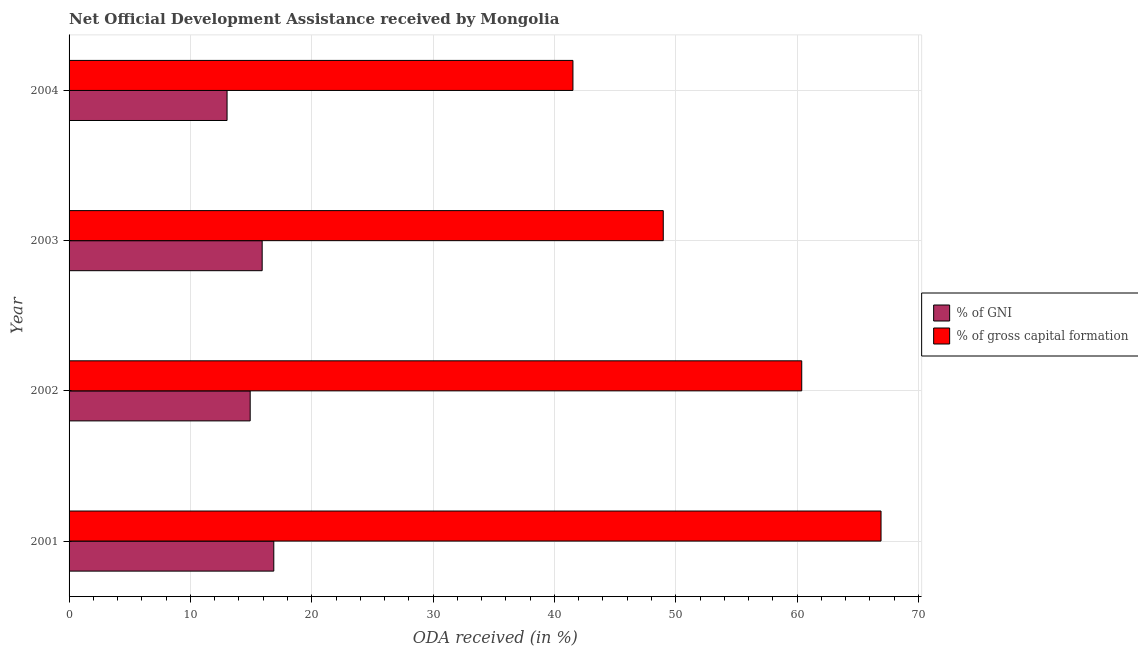Are the number of bars per tick equal to the number of legend labels?
Offer a terse response. Yes. How many bars are there on the 4th tick from the top?
Offer a terse response. 2. What is the label of the 1st group of bars from the top?
Your response must be concise. 2004. What is the oda received as percentage of gross capital formation in 2001?
Offer a terse response. 66.92. Across all years, what is the maximum oda received as percentage of gross capital formation?
Your answer should be very brief. 66.92. Across all years, what is the minimum oda received as percentage of gross capital formation?
Give a very brief answer. 41.53. In which year was the oda received as percentage of gni minimum?
Provide a succinct answer. 2004. What is the total oda received as percentage of gni in the graph?
Provide a succinct answer. 60.74. What is the difference between the oda received as percentage of gross capital formation in 2001 and that in 2002?
Ensure brevity in your answer.  6.54. What is the difference between the oda received as percentage of gni in 2003 and the oda received as percentage of gross capital formation in 2004?
Your answer should be very brief. -25.61. What is the average oda received as percentage of gni per year?
Ensure brevity in your answer.  15.18. In the year 2002, what is the difference between the oda received as percentage of gni and oda received as percentage of gross capital formation?
Your response must be concise. -45.46. In how many years, is the oda received as percentage of gross capital formation greater than 42 %?
Ensure brevity in your answer.  3. What is the ratio of the oda received as percentage of gross capital formation in 2001 to that in 2003?
Your response must be concise. 1.37. Is the difference between the oda received as percentage of gni in 2001 and 2003 greater than the difference between the oda received as percentage of gross capital formation in 2001 and 2003?
Your answer should be compact. No. What is the difference between the highest and the second highest oda received as percentage of gross capital formation?
Provide a short and direct response. 6.54. What is the difference between the highest and the lowest oda received as percentage of gni?
Provide a succinct answer. 3.85. In how many years, is the oda received as percentage of gni greater than the average oda received as percentage of gni taken over all years?
Your response must be concise. 2. What does the 2nd bar from the top in 2003 represents?
Ensure brevity in your answer.  % of GNI. What does the 1st bar from the bottom in 2001 represents?
Ensure brevity in your answer.  % of GNI. Does the graph contain grids?
Offer a terse response. Yes. How are the legend labels stacked?
Provide a short and direct response. Vertical. What is the title of the graph?
Provide a short and direct response. Net Official Development Assistance received by Mongolia. What is the label or title of the X-axis?
Your answer should be compact. ODA received (in %). What is the ODA received (in %) of % of GNI in 2001?
Keep it short and to the point. 16.87. What is the ODA received (in %) of % of gross capital formation in 2001?
Keep it short and to the point. 66.92. What is the ODA received (in %) in % of GNI in 2002?
Ensure brevity in your answer.  14.93. What is the ODA received (in %) in % of gross capital formation in 2002?
Ensure brevity in your answer.  60.38. What is the ODA received (in %) in % of GNI in 2003?
Your response must be concise. 15.91. What is the ODA received (in %) in % of gross capital formation in 2003?
Provide a succinct answer. 48.97. What is the ODA received (in %) in % of GNI in 2004?
Your answer should be very brief. 13.02. What is the ODA received (in %) of % of gross capital formation in 2004?
Keep it short and to the point. 41.53. Across all years, what is the maximum ODA received (in %) of % of GNI?
Keep it short and to the point. 16.87. Across all years, what is the maximum ODA received (in %) of % of gross capital formation?
Ensure brevity in your answer.  66.92. Across all years, what is the minimum ODA received (in %) in % of GNI?
Your response must be concise. 13.02. Across all years, what is the minimum ODA received (in %) in % of gross capital formation?
Your answer should be very brief. 41.53. What is the total ODA received (in %) in % of GNI in the graph?
Offer a terse response. 60.74. What is the total ODA received (in %) of % of gross capital formation in the graph?
Ensure brevity in your answer.  217.8. What is the difference between the ODA received (in %) in % of GNI in 2001 and that in 2002?
Your answer should be compact. 1.95. What is the difference between the ODA received (in %) of % of gross capital formation in 2001 and that in 2002?
Give a very brief answer. 6.54. What is the difference between the ODA received (in %) in % of GNI in 2001 and that in 2003?
Ensure brevity in your answer.  0.96. What is the difference between the ODA received (in %) in % of gross capital formation in 2001 and that in 2003?
Your answer should be very brief. 17.95. What is the difference between the ODA received (in %) of % of GNI in 2001 and that in 2004?
Give a very brief answer. 3.85. What is the difference between the ODA received (in %) of % of gross capital formation in 2001 and that in 2004?
Keep it short and to the point. 25.39. What is the difference between the ODA received (in %) of % of GNI in 2002 and that in 2003?
Offer a terse response. -0.99. What is the difference between the ODA received (in %) in % of gross capital formation in 2002 and that in 2003?
Your response must be concise. 11.41. What is the difference between the ODA received (in %) of % of GNI in 2002 and that in 2004?
Your answer should be compact. 1.91. What is the difference between the ODA received (in %) in % of gross capital formation in 2002 and that in 2004?
Ensure brevity in your answer.  18.86. What is the difference between the ODA received (in %) in % of GNI in 2003 and that in 2004?
Provide a short and direct response. 2.89. What is the difference between the ODA received (in %) in % of gross capital formation in 2003 and that in 2004?
Your answer should be very brief. 7.44. What is the difference between the ODA received (in %) in % of GNI in 2001 and the ODA received (in %) in % of gross capital formation in 2002?
Provide a short and direct response. -43.51. What is the difference between the ODA received (in %) of % of GNI in 2001 and the ODA received (in %) of % of gross capital formation in 2003?
Your response must be concise. -32.1. What is the difference between the ODA received (in %) of % of GNI in 2001 and the ODA received (in %) of % of gross capital formation in 2004?
Provide a succinct answer. -24.65. What is the difference between the ODA received (in %) of % of GNI in 2002 and the ODA received (in %) of % of gross capital formation in 2003?
Provide a succinct answer. -34.04. What is the difference between the ODA received (in %) in % of GNI in 2002 and the ODA received (in %) in % of gross capital formation in 2004?
Offer a very short reply. -26.6. What is the difference between the ODA received (in %) of % of GNI in 2003 and the ODA received (in %) of % of gross capital formation in 2004?
Provide a succinct answer. -25.61. What is the average ODA received (in %) in % of GNI per year?
Your answer should be compact. 15.18. What is the average ODA received (in %) of % of gross capital formation per year?
Make the answer very short. 54.45. In the year 2001, what is the difference between the ODA received (in %) in % of GNI and ODA received (in %) in % of gross capital formation?
Your answer should be very brief. -50.05. In the year 2002, what is the difference between the ODA received (in %) in % of GNI and ODA received (in %) in % of gross capital formation?
Your answer should be compact. -45.46. In the year 2003, what is the difference between the ODA received (in %) of % of GNI and ODA received (in %) of % of gross capital formation?
Keep it short and to the point. -33.06. In the year 2004, what is the difference between the ODA received (in %) in % of GNI and ODA received (in %) in % of gross capital formation?
Offer a very short reply. -28.51. What is the ratio of the ODA received (in %) of % of GNI in 2001 to that in 2002?
Your answer should be compact. 1.13. What is the ratio of the ODA received (in %) of % of gross capital formation in 2001 to that in 2002?
Offer a terse response. 1.11. What is the ratio of the ODA received (in %) of % of GNI in 2001 to that in 2003?
Ensure brevity in your answer.  1.06. What is the ratio of the ODA received (in %) of % of gross capital formation in 2001 to that in 2003?
Your answer should be compact. 1.37. What is the ratio of the ODA received (in %) of % of GNI in 2001 to that in 2004?
Give a very brief answer. 1.3. What is the ratio of the ODA received (in %) of % of gross capital formation in 2001 to that in 2004?
Ensure brevity in your answer.  1.61. What is the ratio of the ODA received (in %) in % of GNI in 2002 to that in 2003?
Offer a terse response. 0.94. What is the ratio of the ODA received (in %) of % of gross capital formation in 2002 to that in 2003?
Keep it short and to the point. 1.23. What is the ratio of the ODA received (in %) of % of GNI in 2002 to that in 2004?
Offer a very short reply. 1.15. What is the ratio of the ODA received (in %) of % of gross capital formation in 2002 to that in 2004?
Offer a very short reply. 1.45. What is the ratio of the ODA received (in %) of % of GNI in 2003 to that in 2004?
Your answer should be compact. 1.22. What is the ratio of the ODA received (in %) in % of gross capital formation in 2003 to that in 2004?
Your answer should be very brief. 1.18. What is the difference between the highest and the second highest ODA received (in %) of % of GNI?
Offer a very short reply. 0.96. What is the difference between the highest and the second highest ODA received (in %) of % of gross capital formation?
Your response must be concise. 6.54. What is the difference between the highest and the lowest ODA received (in %) of % of GNI?
Keep it short and to the point. 3.85. What is the difference between the highest and the lowest ODA received (in %) in % of gross capital formation?
Your response must be concise. 25.39. 